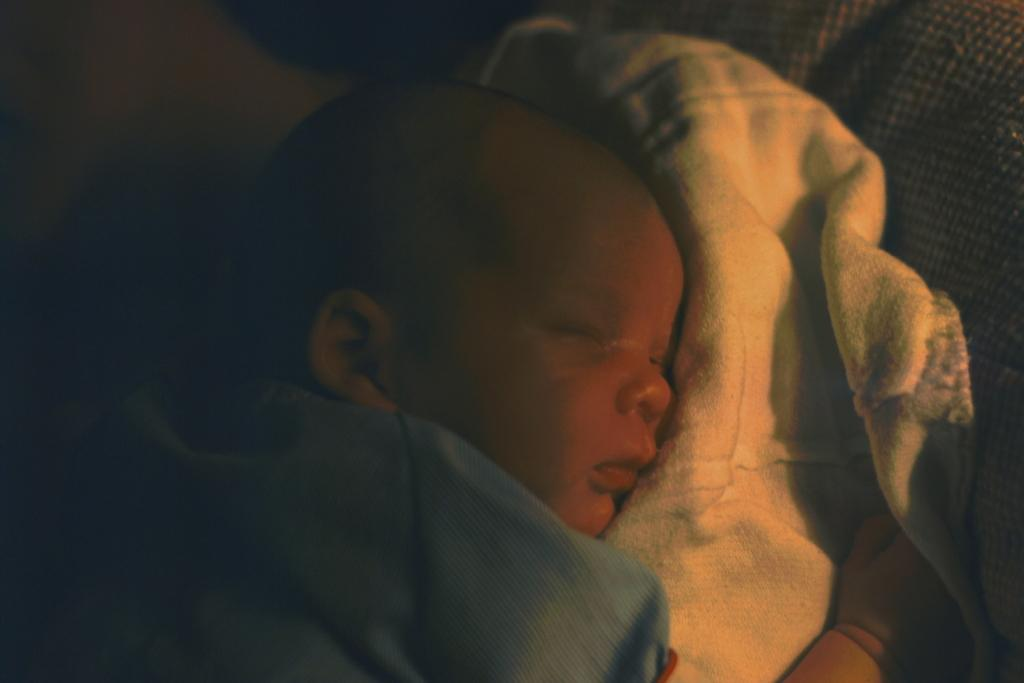What is the main subject of the picture? The main subject of the picture is a baby. What is the baby lying on? The baby is lying on a cloth. What type of iron is being used to support the baby in the picture? There is no iron present in the picture; the baby is lying on a cloth. What relation does the baby have with the person taking the picture? The provided facts do not give any information about the person taking the picture or the baby's relation to them. 